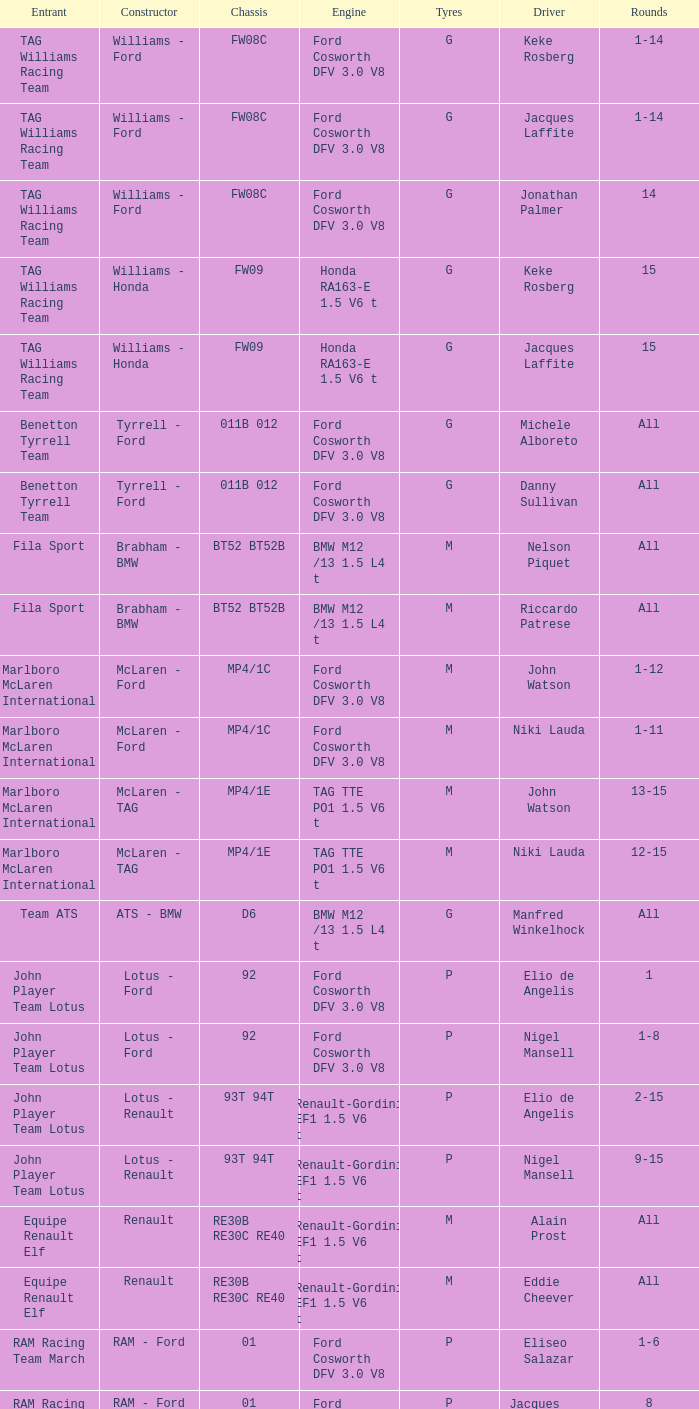Who is driver of the d6 chassis? Manfred Winkelhock. 